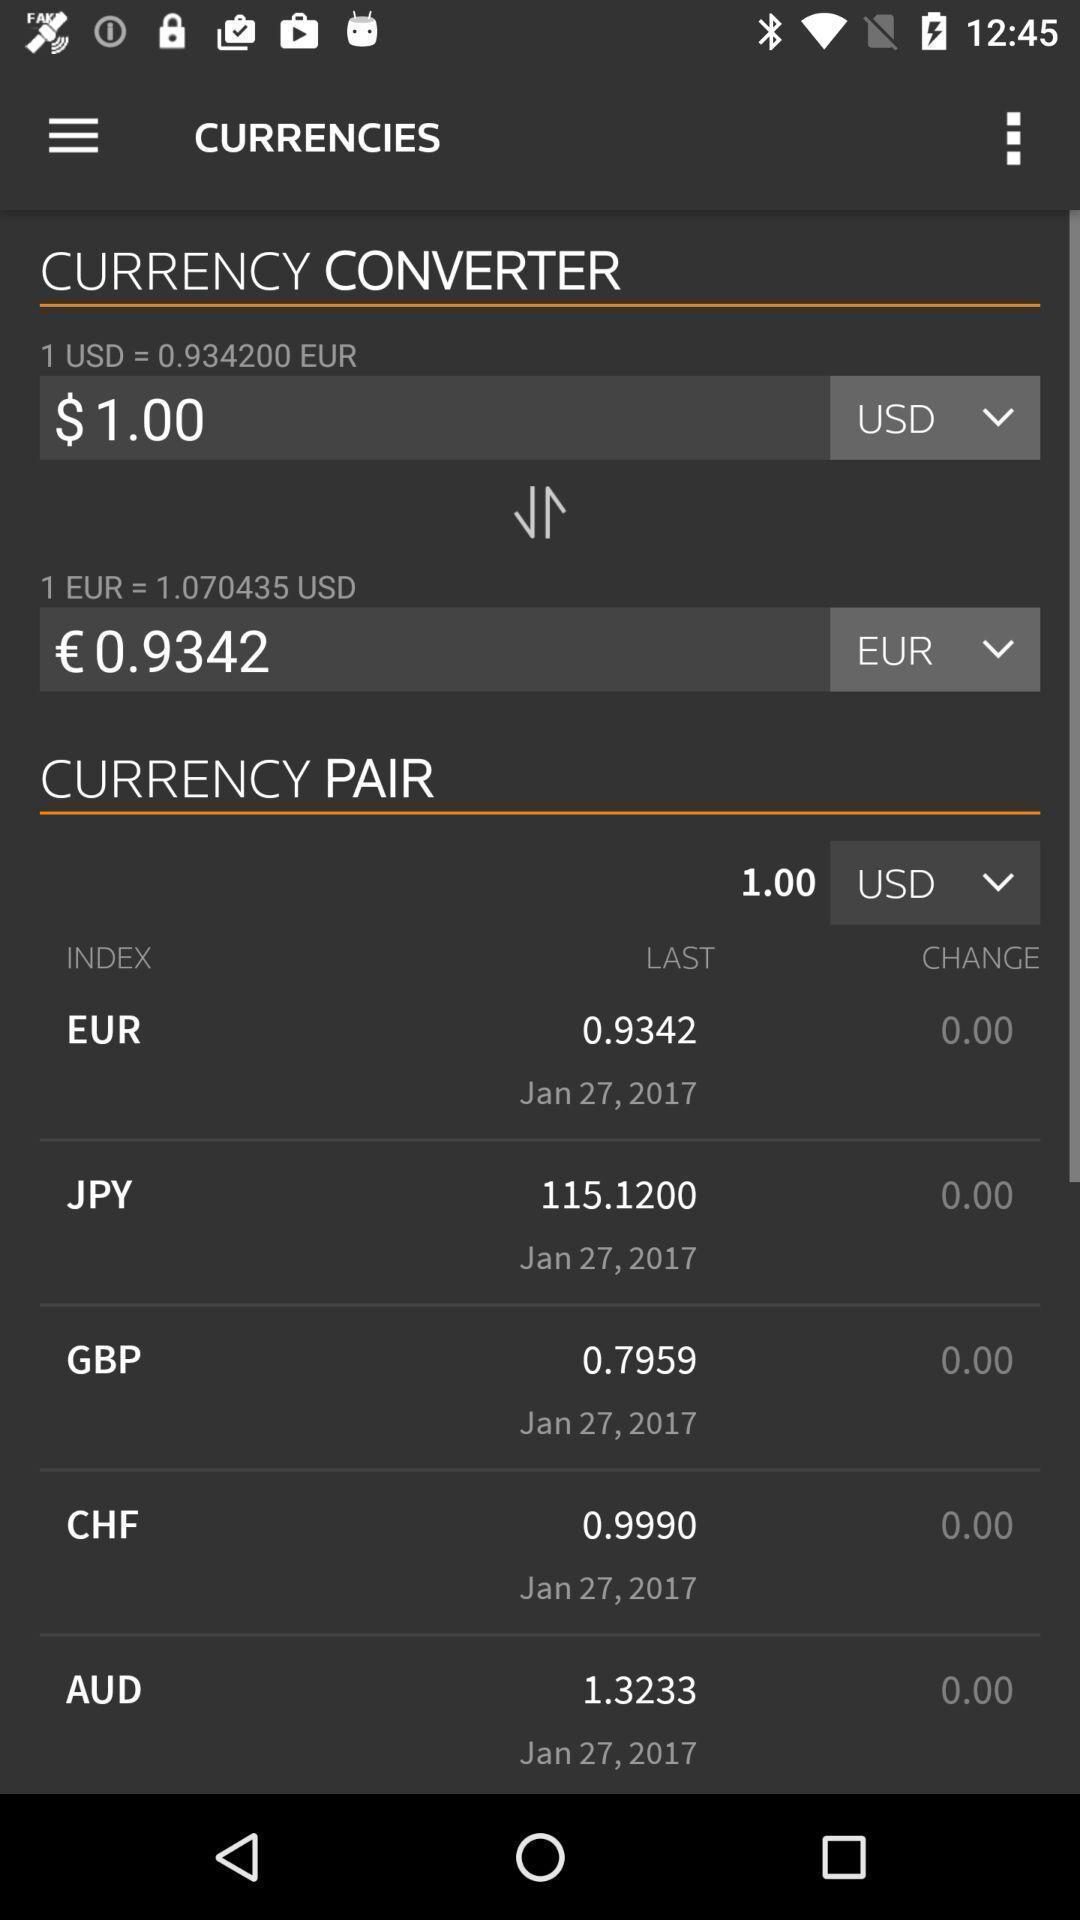Provide a description of this screenshot. Page with currency details in a news app. 